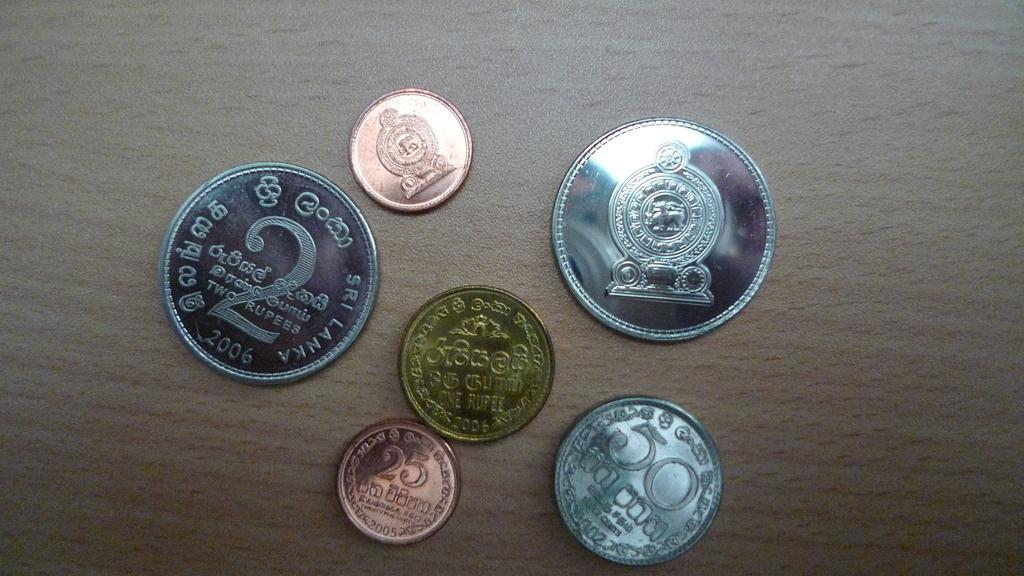<image>
Provide a brief description of the given image. 2, 25 and 50 Rupees are shown on these assorted coins. 